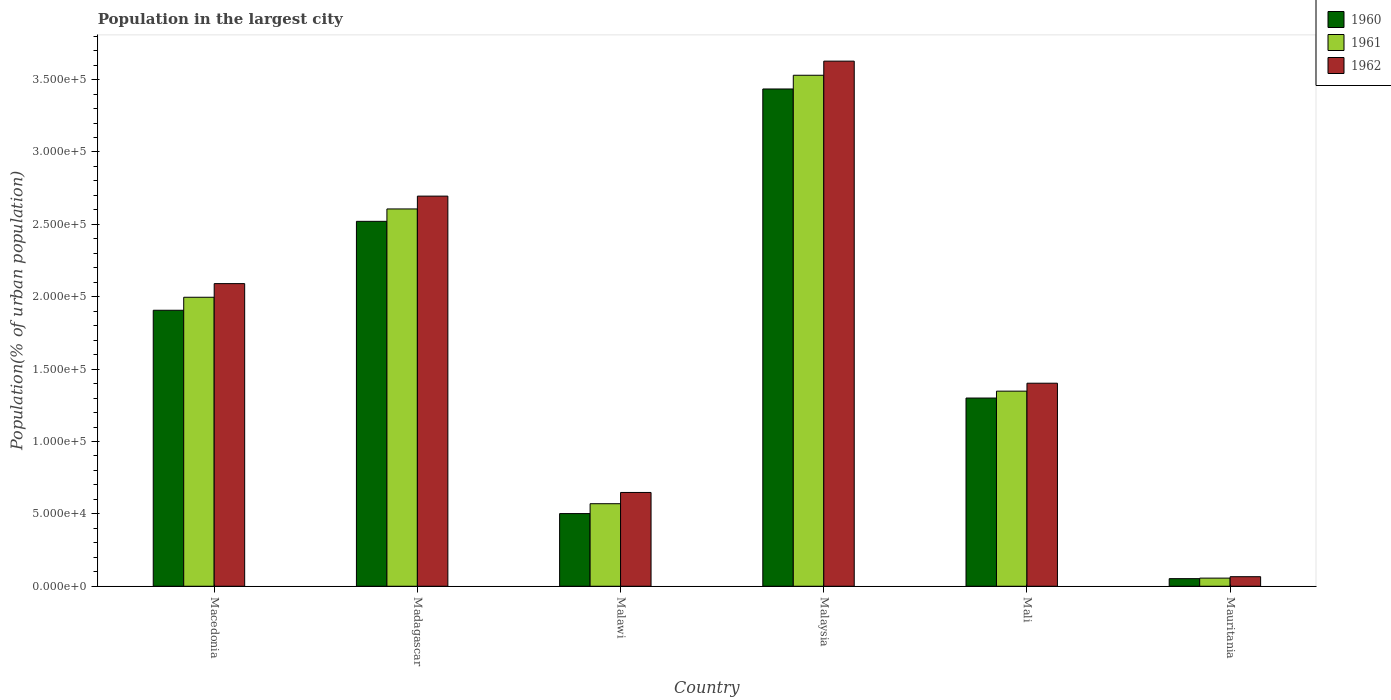How many different coloured bars are there?
Provide a succinct answer. 3. How many groups of bars are there?
Give a very brief answer. 6. Are the number of bars per tick equal to the number of legend labels?
Offer a terse response. Yes. What is the label of the 4th group of bars from the left?
Your answer should be compact. Malaysia. What is the population in the largest city in 1962 in Mauritania?
Ensure brevity in your answer.  6603. Across all countries, what is the maximum population in the largest city in 1962?
Your response must be concise. 3.63e+05. Across all countries, what is the minimum population in the largest city in 1960?
Ensure brevity in your answer.  5254. In which country was the population in the largest city in 1962 maximum?
Provide a short and direct response. Malaysia. In which country was the population in the largest city in 1962 minimum?
Keep it short and to the point. Mauritania. What is the total population in the largest city in 1960 in the graph?
Offer a terse response. 9.72e+05. What is the difference between the population in the largest city in 1961 in Macedonia and that in Mali?
Give a very brief answer. 6.49e+04. What is the difference between the population in the largest city in 1961 in Madagascar and the population in the largest city in 1962 in Mali?
Ensure brevity in your answer.  1.20e+05. What is the average population in the largest city in 1961 per country?
Give a very brief answer. 1.68e+05. What is the difference between the population in the largest city of/in 1962 and population in the largest city of/in 1961 in Mali?
Offer a very short reply. 5483. In how many countries, is the population in the largest city in 1960 greater than 120000 %?
Your answer should be compact. 4. What is the ratio of the population in the largest city in 1960 in Madagascar to that in Malaysia?
Provide a short and direct response. 0.73. Is the population in the largest city in 1960 in Madagascar less than that in Malaysia?
Your answer should be very brief. Yes. What is the difference between the highest and the second highest population in the largest city in 1962?
Offer a terse response. 9.32e+04. What is the difference between the highest and the lowest population in the largest city in 1962?
Offer a very short reply. 3.56e+05. Is the sum of the population in the largest city in 1961 in Mali and Mauritania greater than the maximum population in the largest city in 1960 across all countries?
Provide a succinct answer. No. Is it the case that in every country, the sum of the population in the largest city in 1961 and population in the largest city in 1960 is greater than the population in the largest city in 1962?
Give a very brief answer. Yes. How many countries are there in the graph?
Ensure brevity in your answer.  6. What is the difference between two consecutive major ticks on the Y-axis?
Provide a succinct answer. 5.00e+04. Are the values on the major ticks of Y-axis written in scientific E-notation?
Offer a terse response. Yes. Does the graph contain any zero values?
Your response must be concise. No. Does the graph contain grids?
Your response must be concise. No. Where does the legend appear in the graph?
Offer a terse response. Top right. How many legend labels are there?
Provide a succinct answer. 3. What is the title of the graph?
Your response must be concise. Population in the largest city. Does "2015" appear as one of the legend labels in the graph?
Keep it short and to the point. No. What is the label or title of the Y-axis?
Offer a very short reply. Population(% of urban population). What is the Population(% of urban population) in 1960 in Macedonia?
Keep it short and to the point. 1.91e+05. What is the Population(% of urban population) of 1961 in Macedonia?
Offer a terse response. 2.00e+05. What is the Population(% of urban population) of 1962 in Macedonia?
Make the answer very short. 2.09e+05. What is the Population(% of urban population) in 1960 in Madagascar?
Give a very brief answer. 2.52e+05. What is the Population(% of urban population) of 1961 in Madagascar?
Keep it short and to the point. 2.61e+05. What is the Population(% of urban population) in 1962 in Madagascar?
Your answer should be compact. 2.70e+05. What is the Population(% of urban population) of 1960 in Malawi?
Give a very brief answer. 5.02e+04. What is the Population(% of urban population) in 1961 in Malawi?
Keep it short and to the point. 5.70e+04. What is the Population(% of urban population) in 1962 in Malawi?
Your answer should be very brief. 6.48e+04. What is the Population(% of urban population) of 1960 in Malaysia?
Offer a terse response. 3.44e+05. What is the Population(% of urban population) in 1961 in Malaysia?
Provide a short and direct response. 3.53e+05. What is the Population(% of urban population) in 1962 in Malaysia?
Provide a short and direct response. 3.63e+05. What is the Population(% of urban population) in 1960 in Mali?
Give a very brief answer. 1.30e+05. What is the Population(% of urban population) in 1961 in Mali?
Offer a terse response. 1.35e+05. What is the Population(% of urban population) of 1962 in Mali?
Ensure brevity in your answer.  1.40e+05. What is the Population(% of urban population) in 1960 in Mauritania?
Offer a very short reply. 5254. What is the Population(% of urban population) in 1961 in Mauritania?
Your answer should be compact. 5616. What is the Population(% of urban population) of 1962 in Mauritania?
Your answer should be very brief. 6603. Across all countries, what is the maximum Population(% of urban population) of 1960?
Your answer should be compact. 3.44e+05. Across all countries, what is the maximum Population(% of urban population) of 1961?
Offer a terse response. 3.53e+05. Across all countries, what is the maximum Population(% of urban population) of 1962?
Your response must be concise. 3.63e+05. Across all countries, what is the minimum Population(% of urban population) of 1960?
Your answer should be very brief. 5254. Across all countries, what is the minimum Population(% of urban population) in 1961?
Give a very brief answer. 5616. Across all countries, what is the minimum Population(% of urban population) in 1962?
Keep it short and to the point. 6603. What is the total Population(% of urban population) of 1960 in the graph?
Your answer should be very brief. 9.72e+05. What is the total Population(% of urban population) in 1961 in the graph?
Ensure brevity in your answer.  1.01e+06. What is the total Population(% of urban population) in 1962 in the graph?
Your answer should be compact. 1.05e+06. What is the difference between the Population(% of urban population) of 1960 in Macedonia and that in Madagascar?
Provide a short and direct response. -6.14e+04. What is the difference between the Population(% of urban population) of 1961 in Macedonia and that in Madagascar?
Give a very brief answer. -6.10e+04. What is the difference between the Population(% of urban population) in 1962 in Macedonia and that in Madagascar?
Provide a succinct answer. -6.04e+04. What is the difference between the Population(% of urban population) in 1960 in Macedonia and that in Malawi?
Your answer should be very brief. 1.40e+05. What is the difference between the Population(% of urban population) in 1961 in Macedonia and that in Malawi?
Your answer should be compact. 1.43e+05. What is the difference between the Population(% of urban population) in 1962 in Macedonia and that in Malawi?
Make the answer very short. 1.44e+05. What is the difference between the Population(% of urban population) of 1960 in Macedonia and that in Malaysia?
Make the answer very short. -1.53e+05. What is the difference between the Population(% of urban population) of 1961 in Macedonia and that in Malaysia?
Give a very brief answer. -1.53e+05. What is the difference between the Population(% of urban population) in 1962 in Macedonia and that in Malaysia?
Your answer should be compact. -1.54e+05. What is the difference between the Population(% of urban population) of 1960 in Macedonia and that in Mali?
Provide a succinct answer. 6.06e+04. What is the difference between the Population(% of urban population) in 1961 in Macedonia and that in Mali?
Make the answer very short. 6.49e+04. What is the difference between the Population(% of urban population) in 1962 in Macedonia and that in Mali?
Provide a succinct answer. 6.88e+04. What is the difference between the Population(% of urban population) of 1960 in Macedonia and that in Mauritania?
Your answer should be compact. 1.85e+05. What is the difference between the Population(% of urban population) in 1961 in Macedonia and that in Mauritania?
Give a very brief answer. 1.94e+05. What is the difference between the Population(% of urban population) in 1962 in Macedonia and that in Mauritania?
Your response must be concise. 2.02e+05. What is the difference between the Population(% of urban population) of 1960 in Madagascar and that in Malawi?
Provide a succinct answer. 2.02e+05. What is the difference between the Population(% of urban population) in 1961 in Madagascar and that in Malawi?
Give a very brief answer. 2.04e+05. What is the difference between the Population(% of urban population) of 1962 in Madagascar and that in Malawi?
Your answer should be very brief. 2.05e+05. What is the difference between the Population(% of urban population) in 1960 in Madagascar and that in Malaysia?
Ensure brevity in your answer.  -9.14e+04. What is the difference between the Population(% of urban population) in 1961 in Madagascar and that in Malaysia?
Your answer should be very brief. -9.24e+04. What is the difference between the Population(% of urban population) in 1962 in Madagascar and that in Malaysia?
Provide a short and direct response. -9.32e+04. What is the difference between the Population(% of urban population) in 1960 in Madagascar and that in Mali?
Provide a short and direct response. 1.22e+05. What is the difference between the Population(% of urban population) in 1961 in Madagascar and that in Mali?
Provide a short and direct response. 1.26e+05. What is the difference between the Population(% of urban population) in 1962 in Madagascar and that in Mali?
Make the answer very short. 1.29e+05. What is the difference between the Population(% of urban population) in 1960 in Madagascar and that in Mauritania?
Offer a terse response. 2.47e+05. What is the difference between the Population(% of urban population) of 1961 in Madagascar and that in Mauritania?
Offer a terse response. 2.55e+05. What is the difference between the Population(% of urban population) of 1962 in Madagascar and that in Mauritania?
Your response must be concise. 2.63e+05. What is the difference between the Population(% of urban population) of 1960 in Malawi and that in Malaysia?
Offer a very short reply. -2.93e+05. What is the difference between the Population(% of urban population) in 1961 in Malawi and that in Malaysia?
Offer a terse response. -2.96e+05. What is the difference between the Population(% of urban population) in 1962 in Malawi and that in Malaysia?
Keep it short and to the point. -2.98e+05. What is the difference between the Population(% of urban population) in 1960 in Malawi and that in Mali?
Provide a succinct answer. -7.98e+04. What is the difference between the Population(% of urban population) in 1961 in Malawi and that in Mali?
Offer a very short reply. -7.78e+04. What is the difference between the Population(% of urban population) of 1962 in Malawi and that in Mali?
Your response must be concise. -7.55e+04. What is the difference between the Population(% of urban population) of 1960 in Malawi and that in Mauritania?
Your response must be concise. 4.49e+04. What is the difference between the Population(% of urban population) of 1961 in Malawi and that in Mauritania?
Make the answer very short. 5.14e+04. What is the difference between the Population(% of urban population) of 1962 in Malawi and that in Mauritania?
Offer a terse response. 5.82e+04. What is the difference between the Population(% of urban population) of 1960 in Malaysia and that in Mali?
Your answer should be very brief. 2.14e+05. What is the difference between the Population(% of urban population) in 1961 in Malaysia and that in Mali?
Make the answer very short. 2.18e+05. What is the difference between the Population(% of urban population) of 1962 in Malaysia and that in Mali?
Offer a terse response. 2.23e+05. What is the difference between the Population(% of urban population) of 1960 in Malaysia and that in Mauritania?
Ensure brevity in your answer.  3.38e+05. What is the difference between the Population(% of urban population) in 1961 in Malaysia and that in Mauritania?
Your answer should be compact. 3.47e+05. What is the difference between the Population(% of urban population) of 1962 in Malaysia and that in Mauritania?
Provide a succinct answer. 3.56e+05. What is the difference between the Population(% of urban population) in 1960 in Mali and that in Mauritania?
Make the answer very short. 1.25e+05. What is the difference between the Population(% of urban population) of 1961 in Mali and that in Mauritania?
Offer a very short reply. 1.29e+05. What is the difference between the Population(% of urban population) in 1962 in Mali and that in Mauritania?
Offer a terse response. 1.34e+05. What is the difference between the Population(% of urban population) in 1960 in Macedonia and the Population(% of urban population) in 1961 in Madagascar?
Your answer should be compact. -7.00e+04. What is the difference between the Population(% of urban population) of 1960 in Macedonia and the Population(% of urban population) of 1962 in Madagascar?
Provide a short and direct response. -7.89e+04. What is the difference between the Population(% of urban population) of 1961 in Macedonia and the Population(% of urban population) of 1962 in Madagascar?
Make the answer very short. -6.99e+04. What is the difference between the Population(% of urban population) of 1960 in Macedonia and the Population(% of urban population) of 1961 in Malawi?
Provide a succinct answer. 1.34e+05. What is the difference between the Population(% of urban population) in 1960 in Macedonia and the Population(% of urban population) in 1962 in Malawi?
Keep it short and to the point. 1.26e+05. What is the difference between the Population(% of urban population) of 1961 in Macedonia and the Population(% of urban population) of 1962 in Malawi?
Offer a very short reply. 1.35e+05. What is the difference between the Population(% of urban population) of 1960 in Macedonia and the Population(% of urban population) of 1961 in Malaysia?
Offer a very short reply. -1.62e+05. What is the difference between the Population(% of urban population) of 1960 in Macedonia and the Population(% of urban population) of 1962 in Malaysia?
Make the answer very short. -1.72e+05. What is the difference between the Population(% of urban population) of 1961 in Macedonia and the Population(% of urban population) of 1962 in Malaysia?
Ensure brevity in your answer.  -1.63e+05. What is the difference between the Population(% of urban population) in 1960 in Macedonia and the Population(% of urban population) in 1961 in Mali?
Your answer should be compact. 5.59e+04. What is the difference between the Population(% of urban population) of 1960 in Macedonia and the Population(% of urban population) of 1962 in Mali?
Keep it short and to the point. 5.04e+04. What is the difference between the Population(% of urban population) of 1961 in Macedonia and the Population(% of urban population) of 1962 in Mali?
Provide a short and direct response. 5.94e+04. What is the difference between the Population(% of urban population) in 1960 in Macedonia and the Population(% of urban population) in 1961 in Mauritania?
Provide a short and direct response. 1.85e+05. What is the difference between the Population(% of urban population) in 1960 in Macedonia and the Population(% of urban population) in 1962 in Mauritania?
Your response must be concise. 1.84e+05. What is the difference between the Population(% of urban population) in 1961 in Macedonia and the Population(% of urban population) in 1962 in Mauritania?
Offer a very short reply. 1.93e+05. What is the difference between the Population(% of urban population) of 1960 in Madagascar and the Population(% of urban population) of 1961 in Malawi?
Provide a short and direct response. 1.95e+05. What is the difference between the Population(% of urban population) of 1960 in Madagascar and the Population(% of urban population) of 1962 in Malawi?
Offer a very short reply. 1.87e+05. What is the difference between the Population(% of urban population) of 1961 in Madagascar and the Population(% of urban population) of 1962 in Malawi?
Ensure brevity in your answer.  1.96e+05. What is the difference between the Population(% of urban population) in 1960 in Madagascar and the Population(% of urban population) in 1961 in Malaysia?
Ensure brevity in your answer.  -1.01e+05. What is the difference between the Population(% of urban population) of 1960 in Madagascar and the Population(% of urban population) of 1962 in Malaysia?
Ensure brevity in your answer.  -1.11e+05. What is the difference between the Population(% of urban population) in 1961 in Madagascar and the Population(% of urban population) in 1962 in Malaysia?
Ensure brevity in your answer.  -1.02e+05. What is the difference between the Population(% of urban population) in 1960 in Madagascar and the Population(% of urban population) in 1961 in Mali?
Your response must be concise. 1.17e+05. What is the difference between the Population(% of urban population) in 1960 in Madagascar and the Population(% of urban population) in 1962 in Mali?
Your answer should be very brief. 1.12e+05. What is the difference between the Population(% of urban population) of 1961 in Madagascar and the Population(% of urban population) of 1962 in Mali?
Provide a short and direct response. 1.20e+05. What is the difference between the Population(% of urban population) of 1960 in Madagascar and the Population(% of urban population) of 1961 in Mauritania?
Offer a terse response. 2.46e+05. What is the difference between the Population(% of urban population) in 1960 in Madagascar and the Population(% of urban population) in 1962 in Mauritania?
Offer a terse response. 2.45e+05. What is the difference between the Population(% of urban population) of 1961 in Madagascar and the Population(% of urban population) of 1962 in Mauritania?
Your response must be concise. 2.54e+05. What is the difference between the Population(% of urban population) in 1960 in Malawi and the Population(% of urban population) in 1961 in Malaysia?
Give a very brief answer. -3.03e+05. What is the difference between the Population(% of urban population) of 1960 in Malawi and the Population(% of urban population) of 1962 in Malaysia?
Your answer should be very brief. -3.13e+05. What is the difference between the Population(% of urban population) in 1961 in Malawi and the Population(% of urban population) in 1962 in Malaysia?
Your response must be concise. -3.06e+05. What is the difference between the Population(% of urban population) in 1960 in Malawi and the Population(% of urban population) in 1961 in Mali?
Ensure brevity in your answer.  -8.46e+04. What is the difference between the Population(% of urban population) of 1960 in Malawi and the Population(% of urban population) of 1962 in Mali?
Provide a succinct answer. -9.01e+04. What is the difference between the Population(% of urban population) in 1961 in Malawi and the Population(% of urban population) in 1962 in Mali?
Your response must be concise. -8.32e+04. What is the difference between the Population(% of urban population) of 1960 in Malawi and the Population(% of urban population) of 1961 in Mauritania?
Your answer should be compact. 4.46e+04. What is the difference between the Population(% of urban population) in 1960 in Malawi and the Population(% of urban population) in 1962 in Mauritania?
Your response must be concise. 4.36e+04. What is the difference between the Population(% of urban population) of 1961 in Malawi and the Population(% of urban population) of 1962 in Mauritania?
Ensure brevity in your answer.  5.04e+04. What is the difference between the Population(% of urban population) of 1960 in Malaysia and the Population(% of urban population) of 1961 in Mali?
Provide a short and direct response. 2.09e+05. What is the difference between the Population(% of urban population) of 1960 in Malaysia and the Population(% of urban population) of 1962 in Mali?
Your answer should be very brief. 2.03e+05. What is the difference between the Population(% of urban population) in 1961 in Malaysia and the Population(% of urban population) in 1962 in Mali?
Your answer should be compact. 2.13e+05. What is the difference between the Population(% of urban population) in 1960 in Malaysia and the Population(% of urban population) in 1961 in Mauritania?
Keep it short and to the point. 3.38e+05. What is the difference between the Population(% of urban population) of 1960 in Malaysia and the Population(% of urban population) of 1962 in Mauritania?
Give a very brief answer. 3.37e+05. What is the difference between the Population(% of urban population) of 1961 in Malaysia and the Population(% of urban population) of 1962 in Mauritania?
Your answer should be compact. 3.46e+05. What is the difference between the Population(% of urban population) of 1960 in Mali and the Population(% of urban population) of 1961 in Mauritania?
Make the answer very short. 1.24e+05. What is the difference between the Population(% of urban population) of 1960 in Mali and the Population(% of urban population) of 1962 in Mauritania?
Make the answer very short. 1.23e+05. What is the difference between the Population(% of urban population) in 1961 in Mali and the Population(% of urban population) in 1962 in Mauritania?
Your response must be concise. 1.28e+05. What is the average Population(% of urban population) in 1960 per country?
Provide a succinct answer. 1.62e+05. What is the average Population(% of urban population) of 1961 per country?
Give a very brief answer. 1.68e+05. What is the average Population(% of urban population) in 1962 per country?
Make the answer very short. 1.76e+05. What is the difference between the Population(% of urban population) in 1960 and Population(% of urban population) in 1961 in Macedonia?
Your answer should be compact. -8986. What is the difference between the Population(% of urban population) of 1960 and Population(% of urban population) of 1962 in Macedonia?
Offer a terse response. -1.84e+04. What is the difference between the Population(% of urban population) in 1961 and Population(% of urban population) in 1962 in Macedonia?
Keep it short and to the point. -9424. What is the difference between the Population(% of urban population) in 1960 and Population(% of urban population) in 1961 in Madagascar?
Offer a very short reply. -8560. What is the difference between the Population(% of urban population) in 1960 and Population(% of urban population) in 1962 in Madagascar?
Give a very brief answer. -1.74e+04. What is the difference between the Population(% of urban population) of 1961 and Population(% of urban population) of 1962 in Madagascar?
Offer a terse response. -8864. What is the difference between the Population(% of urban population) of 1960 and Population(% of urban population) of 1961 in Malawi?
Provide a short and direct response. -6827. What is the difference between the Population(% of urban population) of 1960 and Population(% of urban population) of 1962 in Malawi?
Offer a very short reply. -1.46e+04. What is the difference between the Population(% of urban population) of 1961 and Population(% of urban population) of 1962 in Malawi?
Provide a succinct answer. -7766. What is the difference between the Population(% of urban population) in 1960 and Population(% of urban population) in 1961 in Malaysia?
Provide a short and direct response. -9483. What is the difference between the Population(% of urban population) in 1960 and Population(% of urban population) in 1962 in Malaysia?
Provide a short and direct response. -1.92e+04. What is the difference between the Population(% of urban population) of 1961 and Population(% of urban population) of 1962 in Malaysia?
Your answer should be very brief. -9758. What is the difference between the Population(% of urban population) of 1960 and Population(% of urban population) of 1961 in Mali?
Offer a terse response. -4767. What is the difference between the Population(% of urban population) in 1960 and Population(% of urban population) in 1962 in Mali?
Give a very brief answer. -1.02e+04. What is the difference between the Population(% of urban population) of 1961 and Population(% of urban population) of 1962 in Mali?
Make the answer very short. -5483. What is the difference between the Population(% of urban population) in 1960 and Population(% of urban population) in 1961 in Mauritania?
Your answer should be compact. -362. What is the difference between the Population(% of urban population) of 1960 and Population(% of urban population) of 1962 in Mauritania?
Your answer should be very brief. -1349. What is the difference between the Population(% of urban population) of 1961 and Population(% of urban population) of 1962 in Mauritania?
Your response must be concise. -987. What is the ratio of the Population(% of urban population) in 1960 in Macedonia to that in Madagascar?
Provide a succinct answer. 0.76. What is the ratio of the Population(% of urban population) in 1961 in Macedonia to that in Madagascar?
Offer a terse response. 0.77. What is the ratio of the Population(% of urban population) of 1962 in Macedonia to that in Madagascar?
Keep it short and to the point. 0.78. What is the ratio of the Population(% of urban population) in 1960 in Macedonia to that in Malawi?
Offer a terse response. 3.8. What is the ratio of the Population(% of urban population) in 1961 in Macedonia to that in Malawi?
Offer a terse response. 3.5. What is the ratio of the Population(% of urban population) of 1962 in Macedonia to that in Malawi?
Your response must be concise. 3.23. What is the ratio of the Population(% of urban population) of 1960 in Macedonia to that in Malaysia?
Offer a very short reply. 0.56. What is the ratio of the Population(% of urban population) of 1961 in Macedonia to that in Malaysia?
Offer a terse response. 0.57. What is the ratio of the Population(% of urban population) in 1962 in Macedonia to that in Malaysia?
Make the answer very short. 0.58. What is the ratio of the Population(% of urban population) in 1960 in Macedonia to that in Mali?
Your answer should be very brief. 1.47. What is the ratio of the Population(% of urban population) in 1961 in Macedonia to that in Mali?
Offer a very short reply. 1.48. What is the ratio of the Population(% of urban population) of 1962 in Macedonia to that in Mali?
Provide a succinct answer. 1.49. What is the ratio of the Population(% of urban population) in 1960 in Macedonia to that in Mauritania?
Give a very brief answer. 36.29. What is the ratio of the Population(% of urban population) of 1961 in Macedonia to that in Mauritania?
Your answer should be very brief. 35.55. What is the ratio of the Population(% of urban population) of 1962 in Macedonia to that in Mauritania?
Your response must be concise. 31.66. What is the ratio of the Population(% of urban population) in 1960 in Madagascar to that in Malawi?
Make the answer very short. 5.02. What is the ratio of the Population(% of urban population) of 1961 in Madagascar to that in Malawi?
Keep it short and to the point. 4.57. What is the ratio of the Population(% of urban population) in 1962 in Madagascar to that in Malawi?
Your response must be concise. 4.16. What is the ratio of the Population(% of urban population) in 1960 in Madagascar to that in Malaysia?
Your response must be concise. 0.73. What is the ratio of the Population(% of urban population) in 1961 in Madagascar to that in Malaysia?
Offer a very short reply. 0.74. What is the ratio of the Population(% of urban population) in 1962 in Madagascar to that in Malaysia?
Offer a very short reply. 0.74. What is the ratio of the Population(% of urban population) in 1960 in Madagascar to that in Mali?
Give a very brief answer. 1.94. What is the ratio of the Population(% of urban population) in 1961 in Madagascar to that in Mali?
Provide a succinct answer. 1.93. What is the ratio of the Population(% of urban population) in 1962 in Madagascar to that in Mali?
Your answer should be very brief. 1.92. What is the ratio of the Population(% of urban population) of 1960 in Madagascar to that in Mauritania?
Offer a terse response. 47.98. What is the ratio of the Population(% of urban population) in 1961 in Madagascar to that in Mauritania?
Provide a succinct answer. 46.41. What is the ratio of the Population(% of urban population) of 1962 in Madagascar to that in Mauritania?
Your answer should be compact. 40.82. What is the ratio of the Population(% of urban population) of 1960 in Malawi to that in Malaysia?
Offer a very short reply. 0.15. What is the ratio of the Population(% of urban population) in 1961 in Malawi to that in Malaysia?
Your answer should be very brief. 0.16. What is the ratio of the Population(% of urban population) of 1962 in Malawi to that in Malaysia?
Offer a terse response. 0.18. What is the ratio of the Population(% of urban population) of 1960 in Malawi to that in Mali?
Make the answer very short. 0.39. What is the ratio of the Population(% of urban population) of 1961 in Malawi to that in Mali?
Your response must be concise. 0.42. What is the ratio of the Population(% of urban population) of 1962 in Malawi to that in Mali?
Offer a terse response. 0.46. What is the ratio of the Population(% of urban population) of 1960 in Malawi to that in Mauritania?
Your answer should be compact. 9.55. What is the ratio of the Population(% of urban population) of 1961 in Malawi to that in Mauritania?
Your answer should be very brief. 10.15. What is the ratio of the Population(% of urban population) in 1962 in Malawi to that in Mauritania?
Ensure brevity in your answer.  9.81. What is the ratio of the Population(% of urban population) in 1960 in Malaysia to that in Mali?
Your answer should be compact. 2.64. What is the ratio of the Population(% of urban population) in 1961 in Malaysia to that in Mali?
Your answer should be compact. 2.62. What is the ratio of the Population(% of urban population) of 1962 in Malaysia to that in Mali?
Give a very brief answer. 2.59. What is the ratio of the Population(% of urban population) in 1960 in Malaysia to that in Mauritania?
Your answer should be very brief. 65.38. What is the ratio of the Population(% of urban population) of 1961 in Malaysia to that in Mauritania?
Provide a succinct answer. 62.86. What is the ratio of the Population(% of urban population) of 1962 in Malaysia to that in Mauritania?
Offer a very short reply. 54.94. What is the ratio of the Population(% of urban population) of 1960 in Mali to that in Mauritania?
Provide a succinct answer. 24.75. What is the ratio of the Population(% of urban population) in 1962 in Mali to that in Mauritania?
Offer a very short reply. 21.24. What is the difference between the highest and the second highest Population(% of urban population) of 1960?
Your answer should be compact. 9.14e+04. What is the difference between the highest and the second highest Population(% of urban population) in 1961?
Your answer should be very brief. 9.24e+04. What is the difference between the highest and the second highest Population(% of urban population) in 1962?
Ensure brevity in your answer.  9.32e+04. What is the difference between the highest and the lowest Population(% of urban population) in 1960?
Ensure brevity in your answer.  3.38e+05. What is the difference between the highest and the lowest Population(% of urban population) in 1961?
Keep it short and to the point. 3.47e+05. What is the difference between the highest and the lowest Population(% of urban population) of 1962?
Offer a terse response. 3.56e+05. 